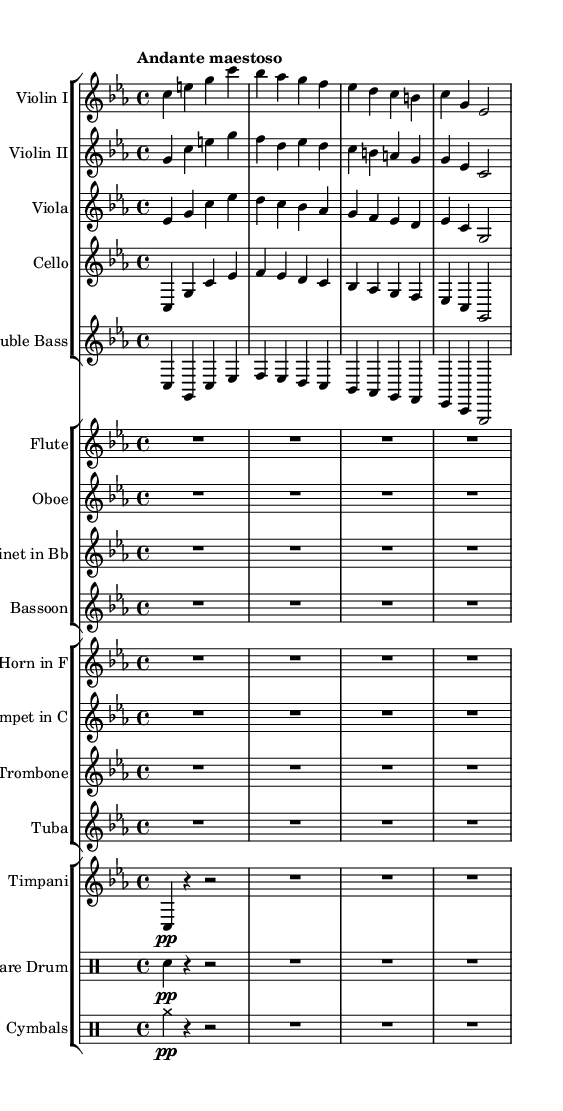What is the key signature of this music? The key signature is C minor, which has three flats: B flat, E flat, and A flat. This is determined by looking at the key indicated in the global settings of the sheet music.
Answer: C minor What is the time signature of this piece? The time signature is 4/4, indicated at the beginning of the score under the global settings. It tells us that there are four beats per measure and that the quarter note gets one beat.
Answer: 4/4 What is the tempo marking of this composition? The tempo marking is "Andante maestoso," which means a moderately slow tempo with a dignified and stately manner. This is noted in the global section of the sheet music.
Answer: Andante maestoso How many measures are in the violin I part? In the provided sheet music, the violin I part contains four measures, as each line is separated by a vertical bar line, which signifies the end of a measure.
Answer: 4 Which instrument makes a sound in the rest measure? The rest measure indicates that the flutes, oboe, clarinet, bassoon, horn, trumpet, trombone, tuba, timpani, snare drum, and cymbals do not play, making this a rest measure for all those instruments as indicated by the rest symbols present.
Answer: All listed instruments What is the instrumentation used in this orchestral piece? The orchestral piece consists of violins (I and II), viola, cello, double bass, flute, oboe, clarinet, bassoon, horn, trumpet, trombone, tuba, timpani, snare drum, and cymbals. This can be identified by the groups of instruments listed in the score.
Answer: Strings, Woodwinds, Brass, Percussion 